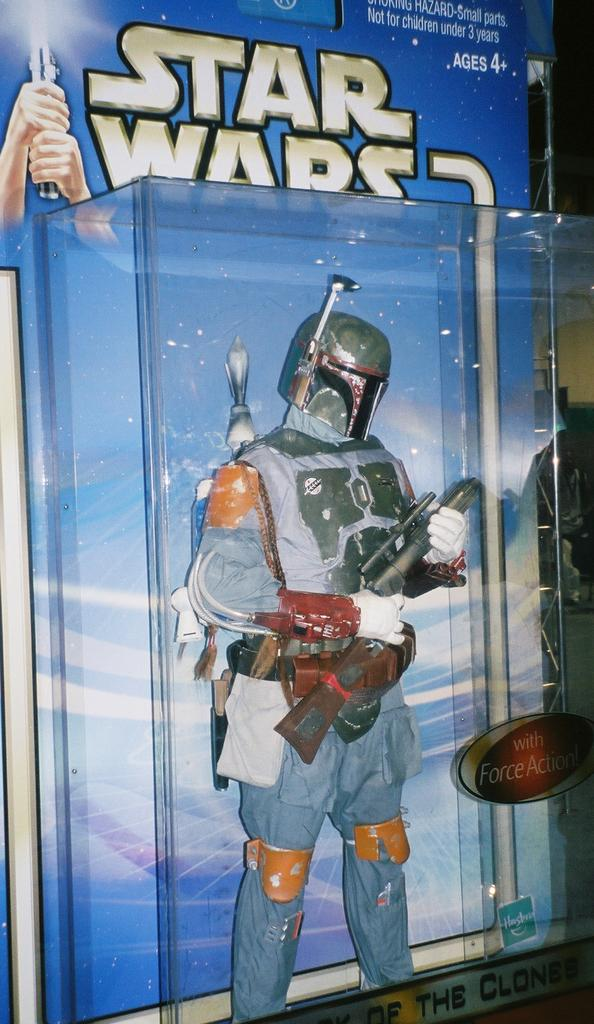Provide a one-sentence caption for the provided image. A Star Wars action figure that is for ages 4 and up. 